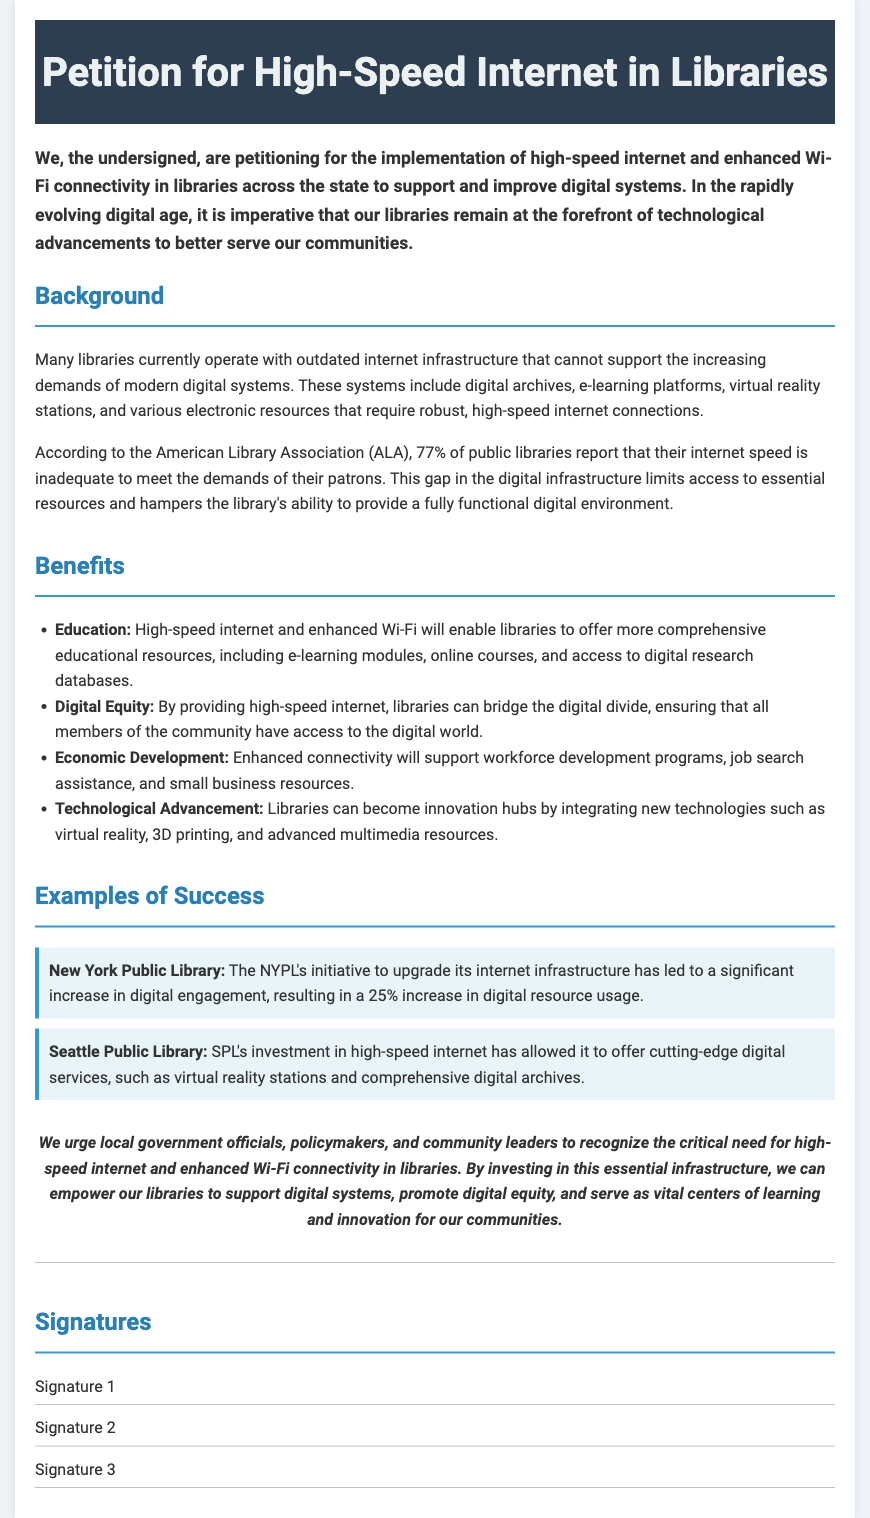What is the title of the petition? The title is explicitly stated in the header of the document, which is "Petition for High-Speed Internet in Libraries."
Answer: Petition for High-Speed Internet in Libraries What percentage of public libraries report inadequate internet speed? The document states that according to the American Library Association (ALA), 77% of public libraries report that their internet speed is inadequate.
Answer: 77% Name one benefit of high-speed internet mentioned in the petition. The document lists several benefits, including education, digital equity, economic development, and technological advancement.
Answer: Education Which library saw a 25% increase in digital resource usage? The example provided in the document refers to the New York Public Library's initiative regarding its internet infrastructure.
Answer: New York Public Library What is the conclusion's primary call to action? The conclusion urges local government officials, policymakers, and community leaders to recognize the critical need for high-speed internet and enhanced Wi-Fi connectivity in libraries.
Answer: Recognize the critical need How many examples of success are provided in the document? The document lists two specific libraries as examples of success related to internet improvements.
Answer: Two 